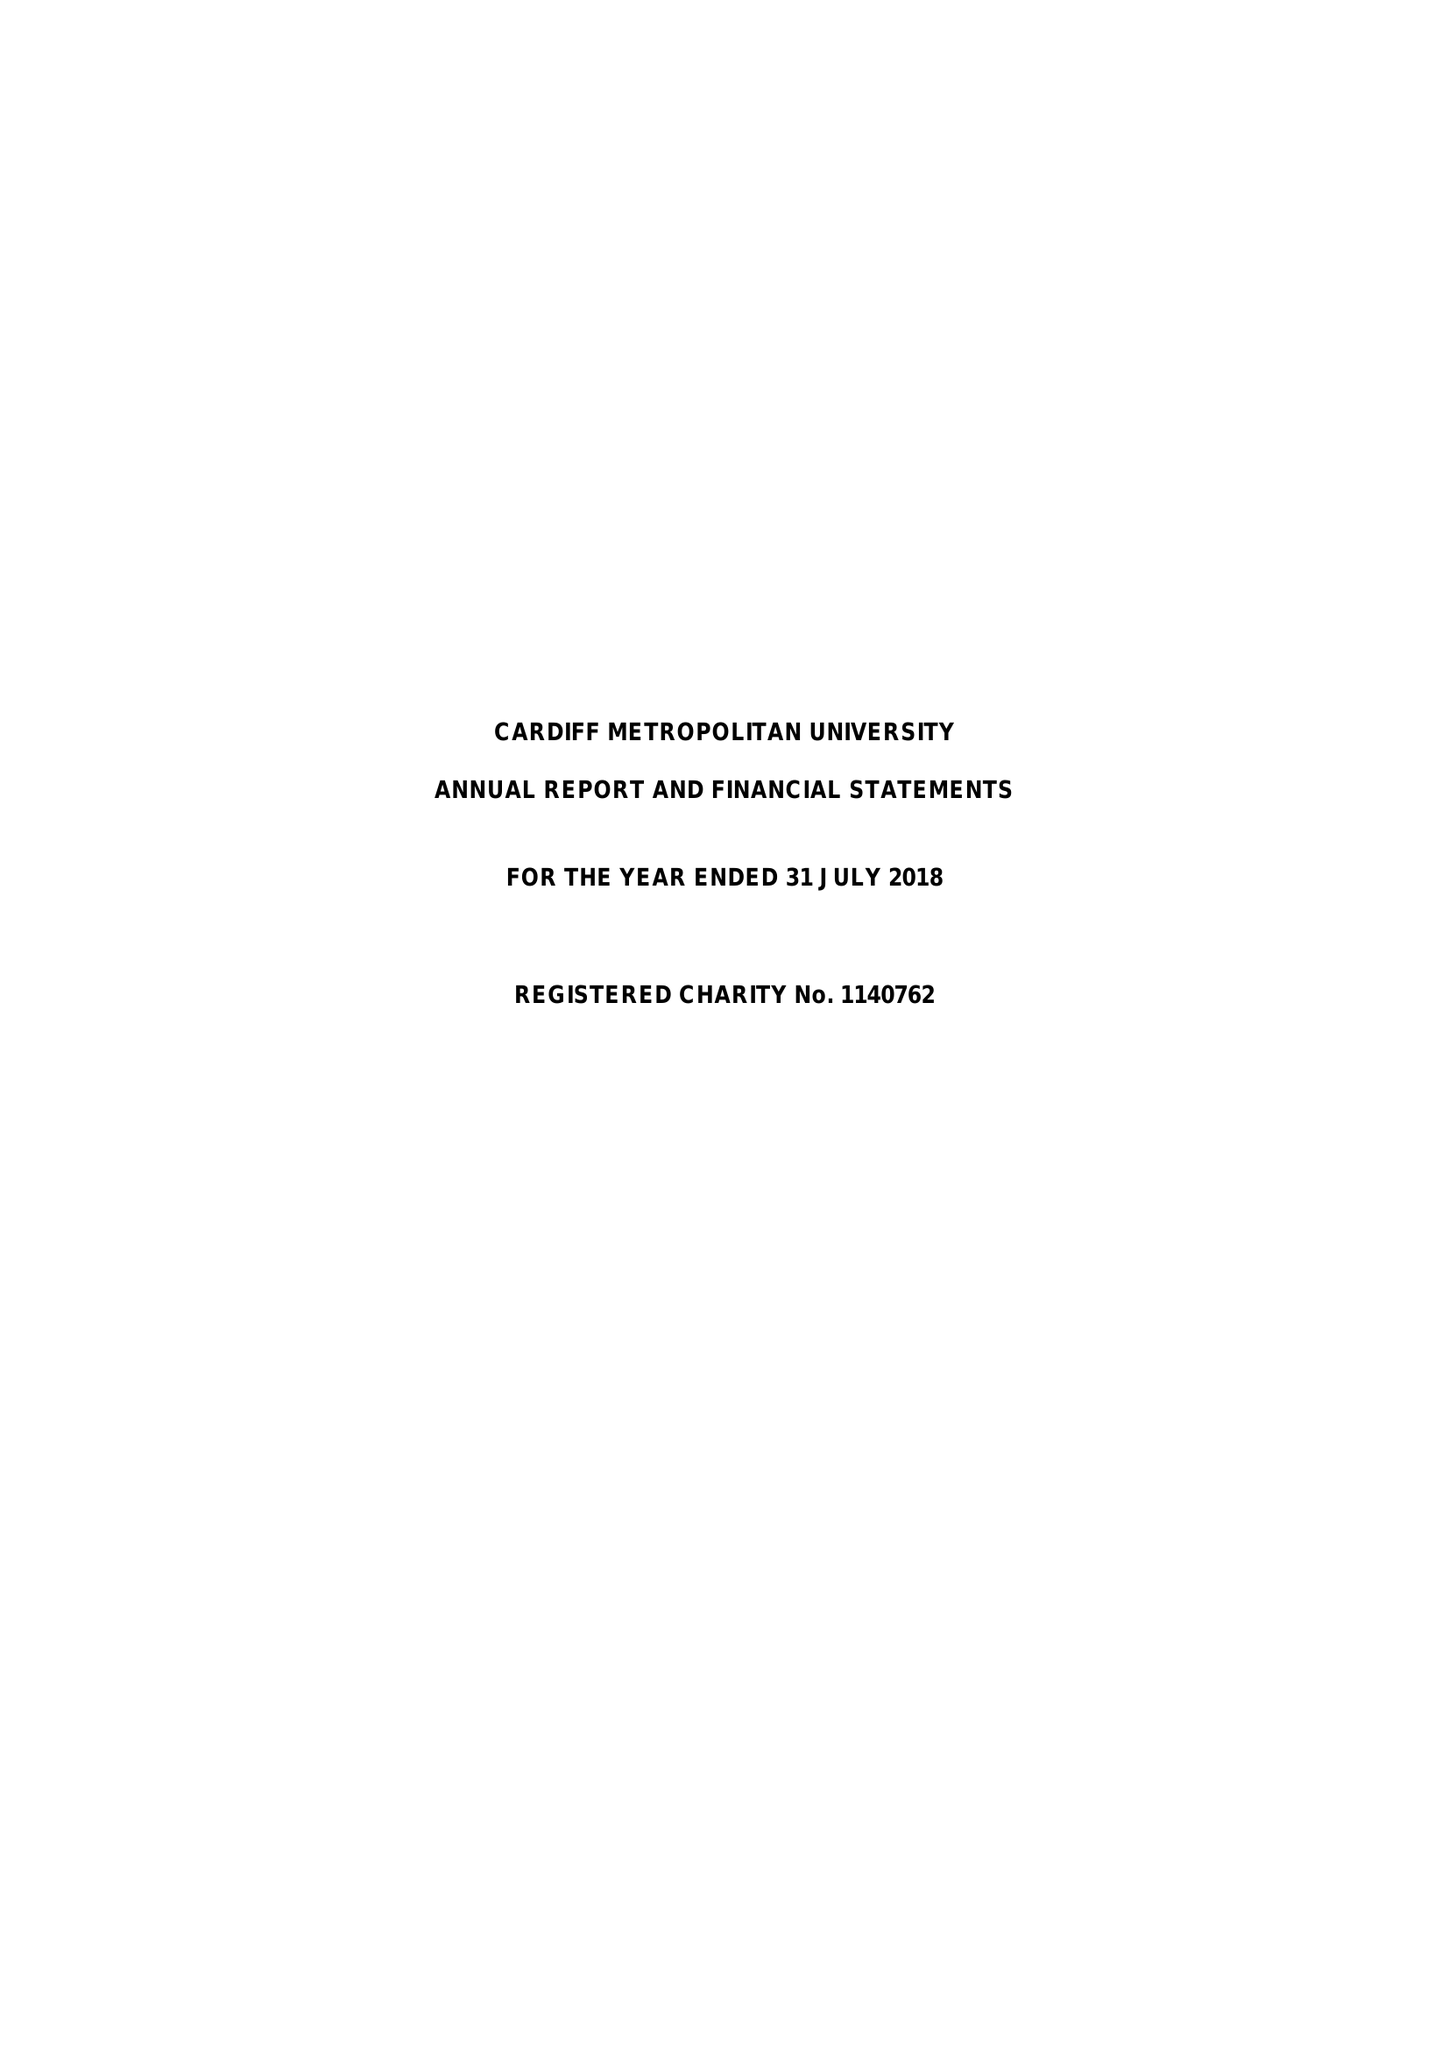What is the value for the spending_annually_in_british_pounds?
Answer the question using a single word or phrase. 100293000.00 